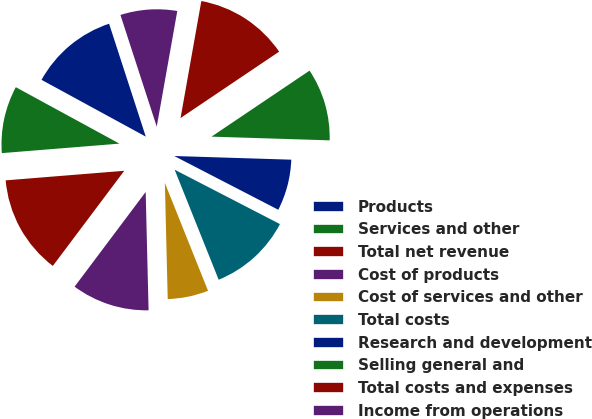Convert chart. <chart><loc_0><loc_0><loc_500><loc_500><pie_chart><fcel>Products<fcel>Services and other<fcel>Total net revenue<fcel>Cost of products<fcel>Cost of services and other<fcel>Total costs<fcel>Research and development<fcel>Selling general and<fcel>Total costs and expenses<fcel>Income from operations<nl><fcel>12.06%<fcel>9.22%<fcel>13.47%<fcel>10.64%<fcel>5.67%<fcel>11.35%<fcel>7.09%<fcel>9.93%<fcel>12.77%<fcel>7.8%<nl></chart> 